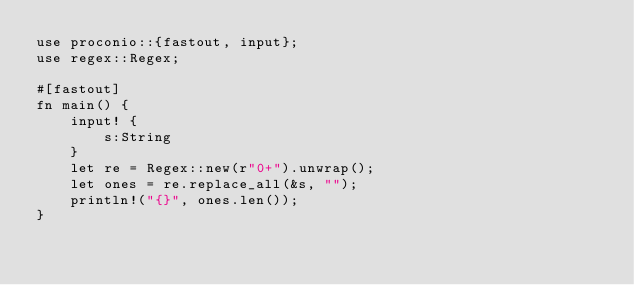<code> <loc_0><loc_0><loc_500><loc_500><_Rust_>use proconio::{fastout, input};
use regex::Regex;

#[fastout]
fn main() {
    input! {
        s:String
    }
    let re = Regex::new(r"0+").unwrap();
    let ones = re.replace_all(&s, "");
    println!("{}", ones.len());
}
</code> 